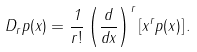<formula> <loc_0><loc_0><loc_500><loc_500>D _ { r } p ( x ) = \frac { 1 } { r ! } \left ( \frac { d } { d x } \right ) ^ { r } \left [ x ^ { r } p ( x ) \right ] .</formula> 